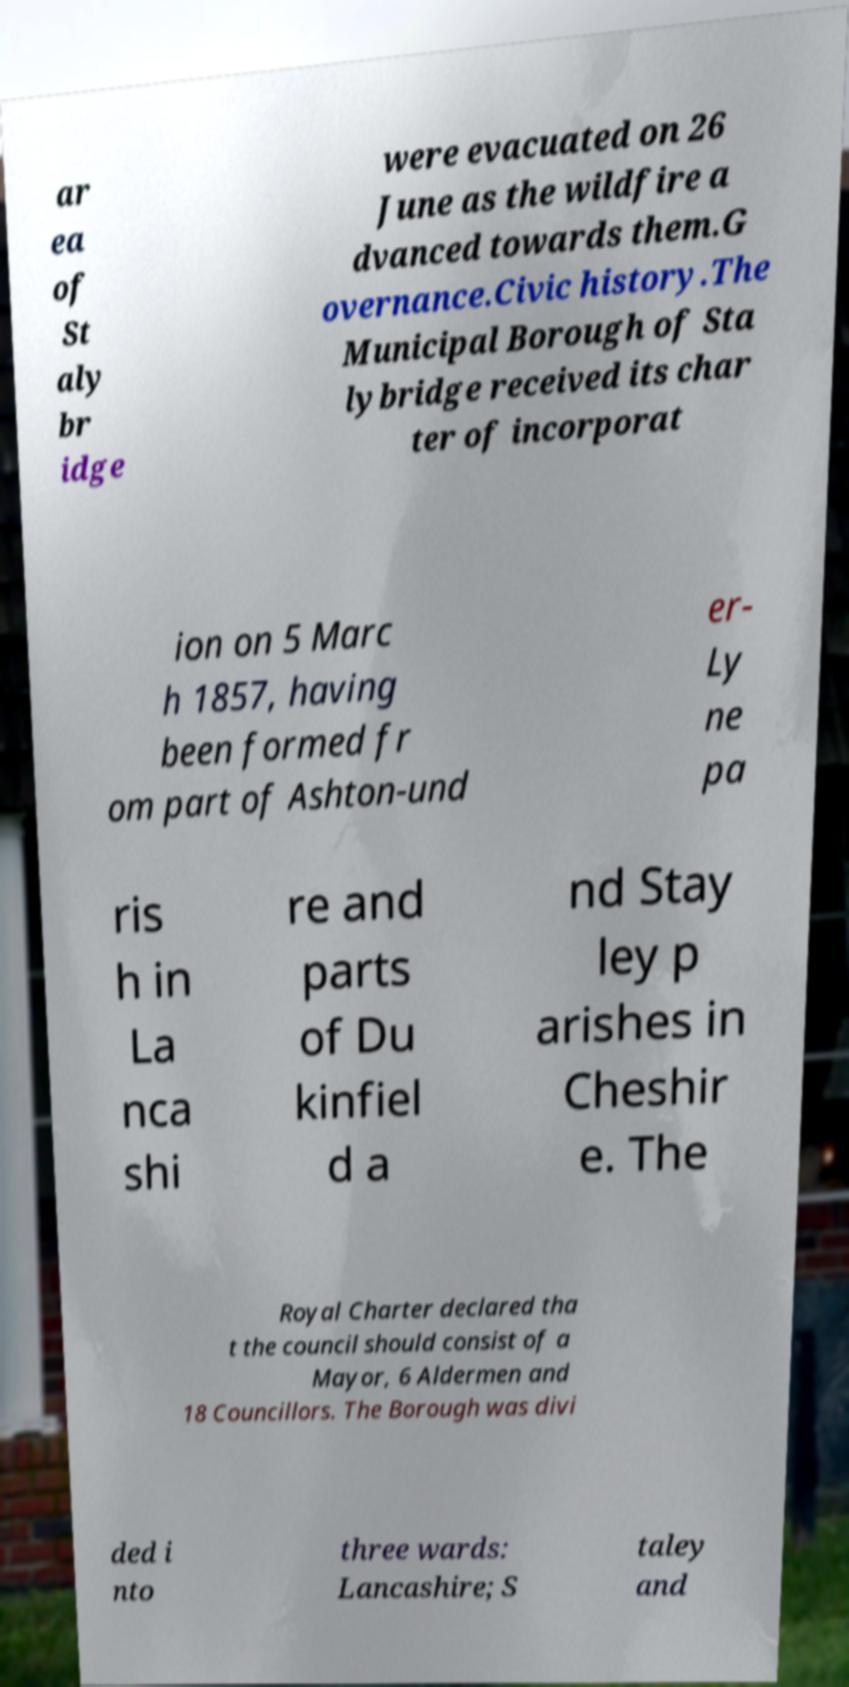Could you extract and type out the text from this image? ar ea of St aly br idge were evacuated on 26 June as the wildfire a dvanced towards them.G overnance.Civic history.The Municipal Borough of Sta lybridge received its char ter of incorporat ion on 5 Marc h 1857, having been formed fr om part of Ashton-und er- Ly ne pa ris h in La nca shi re and parts of Du kinfiel d a nd Stay ley p arishes in Cheshir e. The Royal Charter declared tha t the council should consist of a Mayor, 6 Aldermen and 18 Councillors. The Borough was divi ded i nto three wards: Lancashire; S taley and 